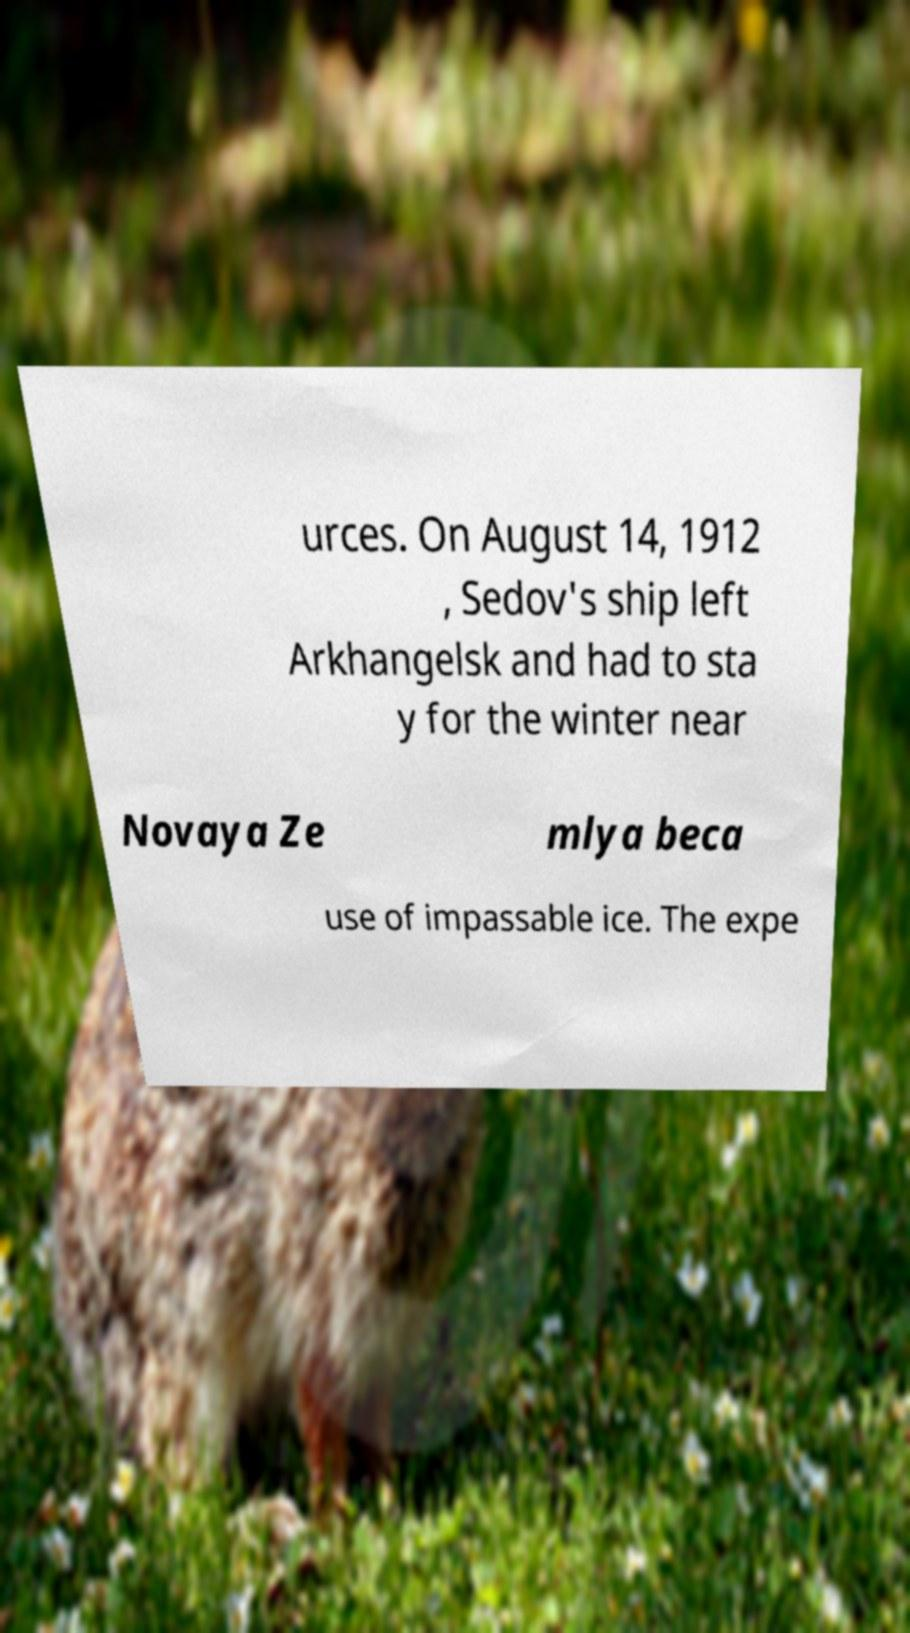Please read and relay the text visible in this image. What does it say? urces. On August 14, 1912 , Sedov's ship left Arkhangelsk and had to sta y for the winter near Novaya Ze mlya beca use of impassable ice. The expe 